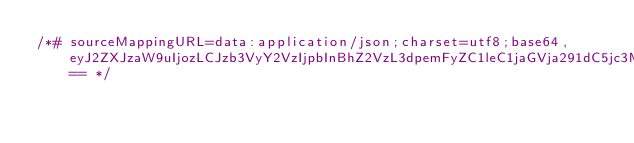<code> <loc_0><loc_0><loc_500><loc_500><_CSS_>/*# sourceMappingURL=data:application/json;charset=utf8;base64,eyJ2ZXJzaW9uIjozLCJzb3VyY2VzIjpbInBhZ2VzL3dpemFyZC1leC1jaGVja291dC5jc3MiXSwibmFtZXMiOltdLCJtYXBwaW5ncyI6IkFBQUE7RUFDRSxnQkFBZ0I7QUFDbEIiLCJmaWxlIjoicGFnZXMvd2l6YXJkLWV4LWNoZWNrb3V0LmNzcyIsInNvdXJjZXNDb250ZW50IjpbIiN3aXphcmQtY2hlY2tvdXQgLmJzLXN0ZXBwZXItaGVhZGVyIHtcbiAgbWF4LXdpZHRoOiA4MDBweDtcbn1cbiJdfQ== */
</code> 